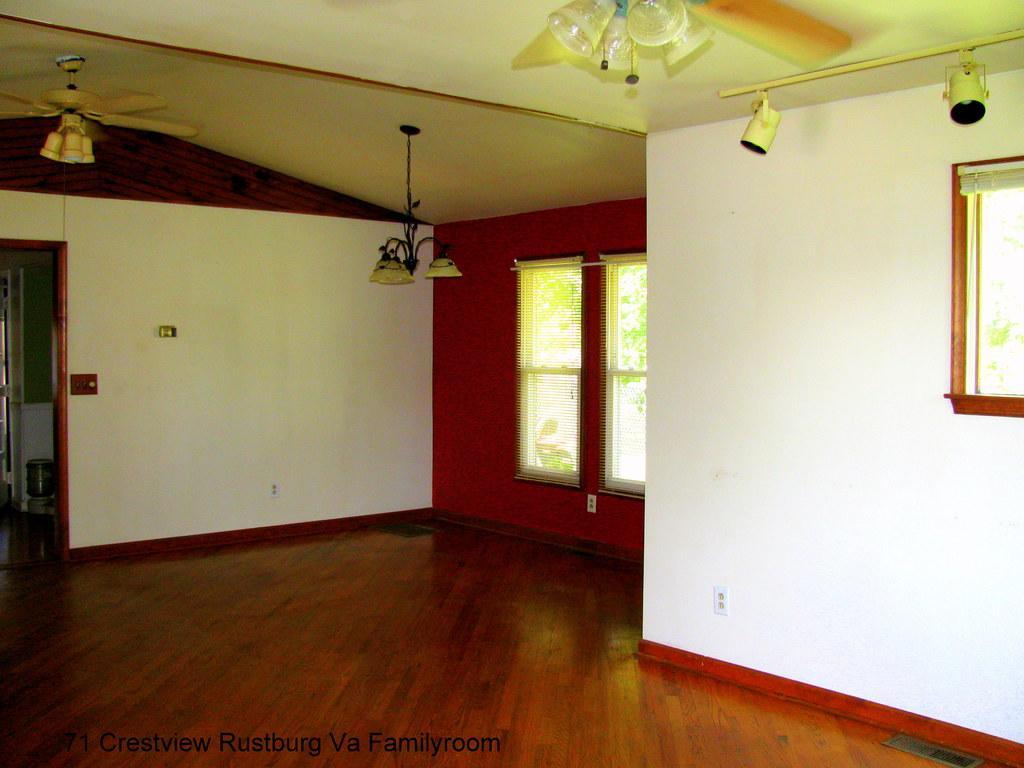How would you summarize this image in a sentence or two? In a given image I can see a window, metal lamps, fan, rods, lights and floor. 